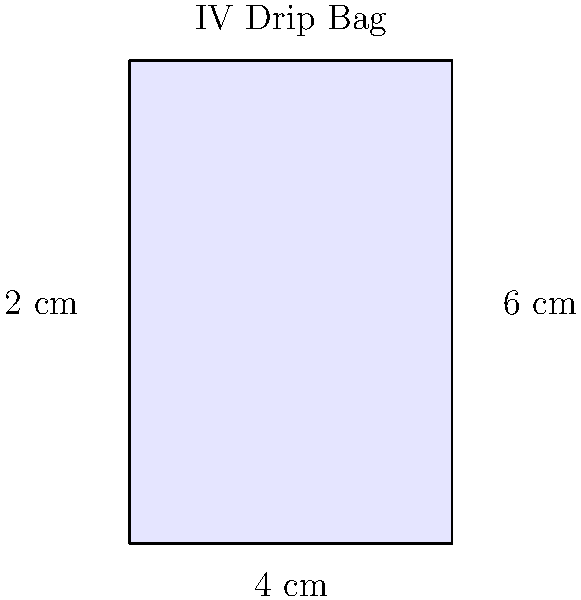Dr. Smith needs to calculate the volume of an IV drip bag for your treatment. The bag is shaped like a rectangular prism with a width of 4 cm, a height of 6 cm, and a depth of 2 cm. What is the volume of the IV bag in cubic centimeters (cm³)? To find the volume of the IV drip bag, we need to use the formula for the volume of a rectangular prism:

$$ V = l \times w \times h $$

Where:
$V$ = volume
$l$ = length (width in this case)
$w$ = width (depth in this case)
$h$ = height

Given dimensions:
- Width (length) = 4 cm
- Height = 6 cm
- Depth (width) = 2 cm

Let's substitute these values into the formula:

$$ V = 4 \text{ cm} \times 2 \text{ cm} \times 6 \text{ cm} $$

Now, let's multiply:

$$ V = 48 \text{ cm}^3 $$

Therefore, the volume of the IV drip bag is 48 cubic centimeters (cm³).
Answer: 48 cm³ 